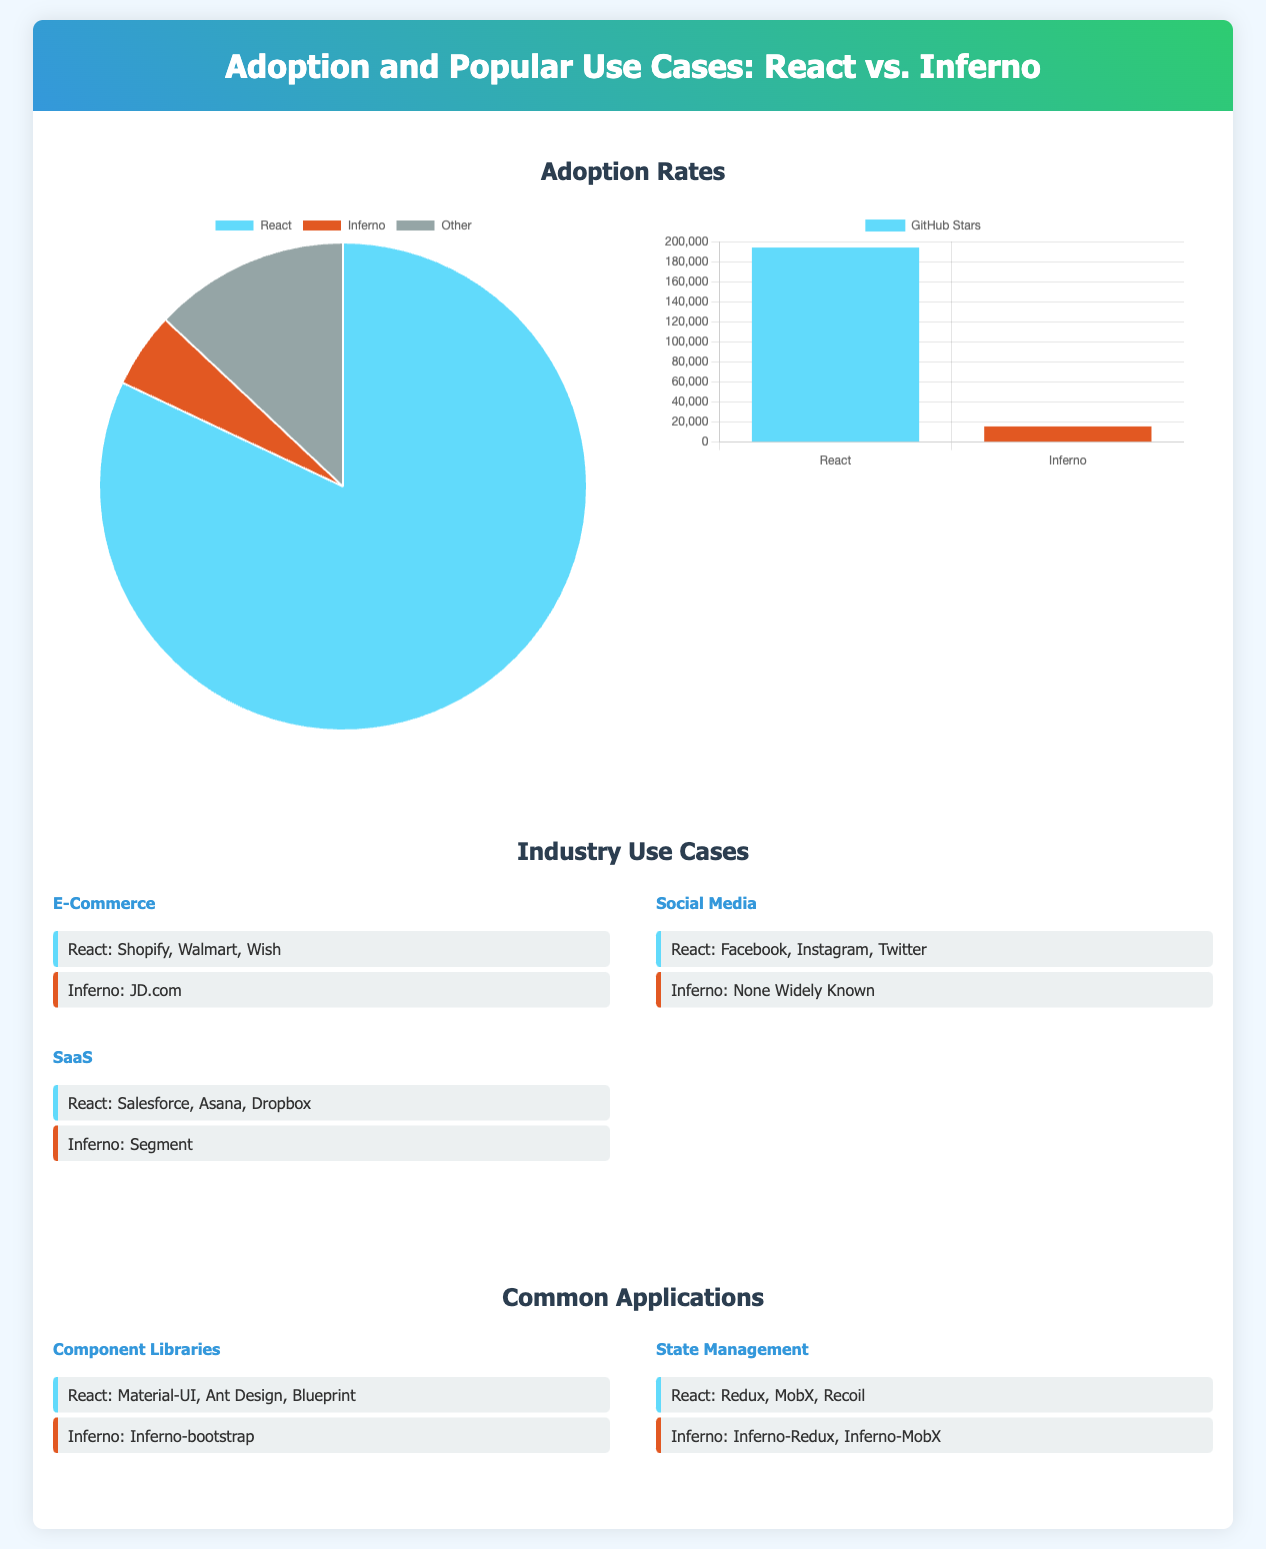What is the overall adoption rate of React? The adoption rate of React is shown in the pie chart that lists the data as 82% for React.
Answer: 82% How many GitHub stars does Inferno have? The community size bar graph shows that Inferno has 15,600 GitHub stars.
Answer: 15,600 Which companies are listed under E-Commerce for React? The comparative list for E-Commerce shows Shopify, Walmart, and Wish as the companies using React.
Answer: Shopify, Walmart, Wish What is the only social media application listed for Inferno? The document mentions that there are no widely known social media applications using Inferno.
Answer: None Widely Known What is the total number of GitHub stars for React and Inferno combined? Adding the GitHub stars from the bar chart: 194,000 (React) + 15,600 (Inferno) = 209,600 stars.
Answer: 209,600 Which component library is associated with Inferno? The document lists Inferno-bootstrap as the component library for Inferno.
Answer: Inferno-bootstrap How many industries are listed for the use cases of React in the document? The comparative lists include three industry sections for E-Commerce, Social Media, and SaaS in the document.
Answer: Three What color is used to represent Inferno in the pie chart? The pie chart uses the color e25822 to represent Inferno in the adoption rate.
Answer: e25822 What application framework is used for state management in React? The document mentions Redux, MobX, and Recoil as state management libraries for React.
Answer: Redux, MobX, Recoil 